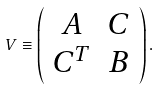Convert formula to latex. <formula><loc_0><loc_0><loc_500><loc_500>V \equiv \left ( \begin{array} { c c } A & C \\ C ^ { T } & B \end{array} \right ) .</formula> 